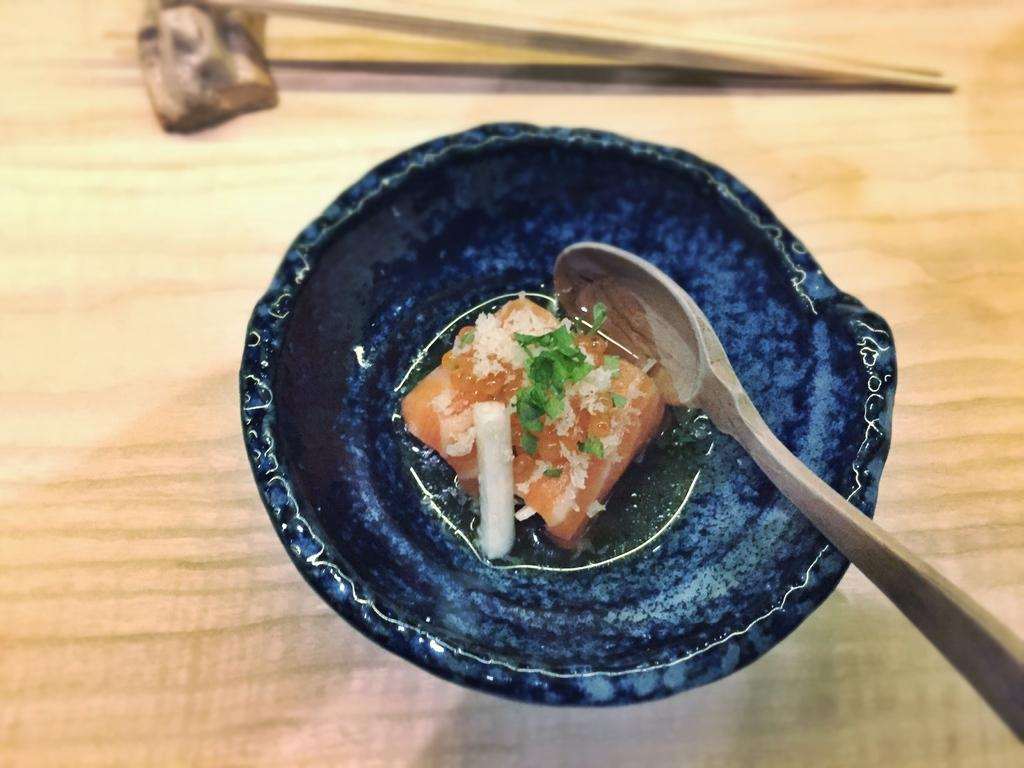What is present in the bowl in the image? There is a food item in the bowl in the image. What is used to eat the food item in the bowl? There is a spoon in the bowl in the image. What surface is the bowl placed on in the image? There is a table at the bottom of the image. What utensil is present on the table in the image? There are chopsticks on the table in the image. How many houses are visible in the image? There are no houses visible in the image; it only features a bowl, a spoon, a food item, a table, and chopsticks. What type of locket is hanging from the spoon in the image? There is no locket present in the image; it only features a bowl, a spoon, a food item, a table, and chopsticks. 